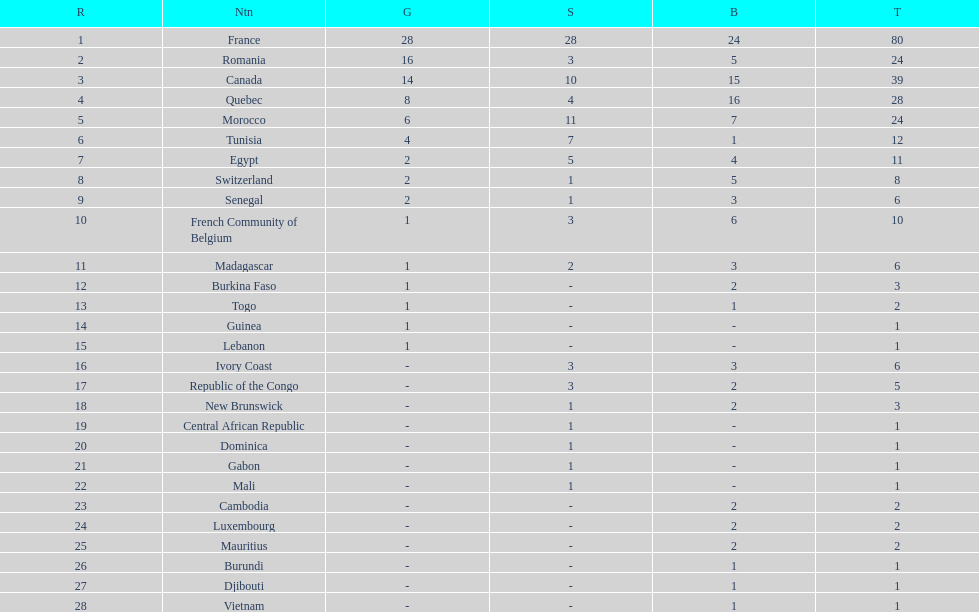What was the total medal count of switzerland? 8. 